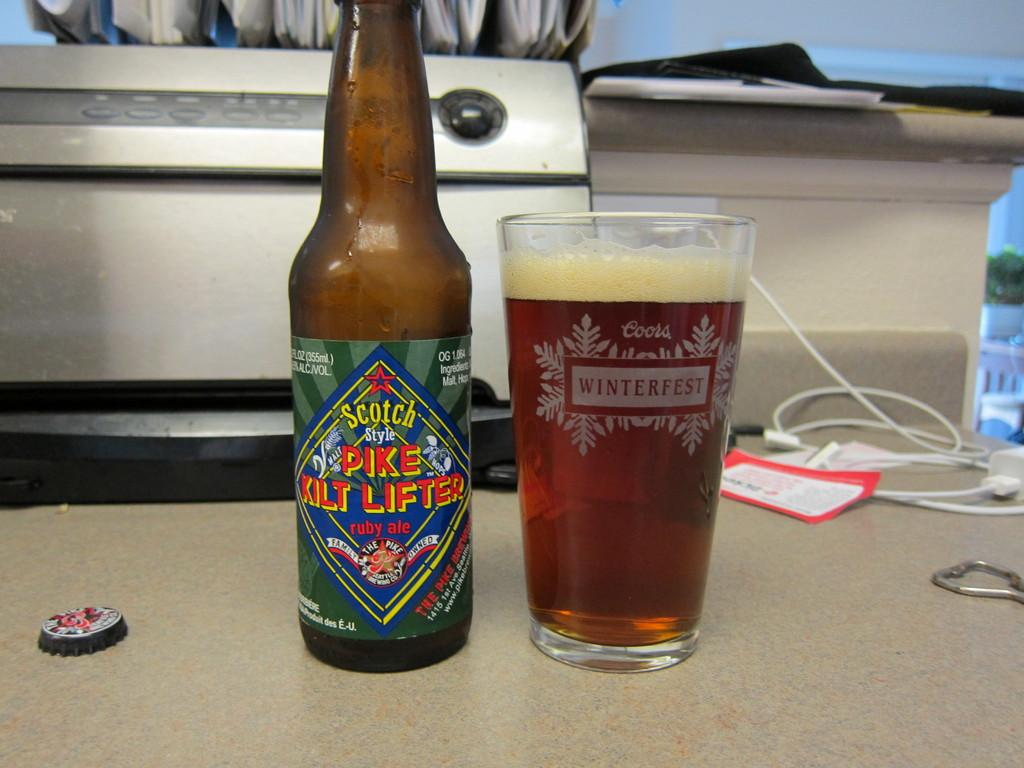<image>
Write a terse but informative summary of the picture. A bottle of Scotch Style Pike Kilt Lifter ruby ale with the beer poured into a Coors Winterfest beer cup. 